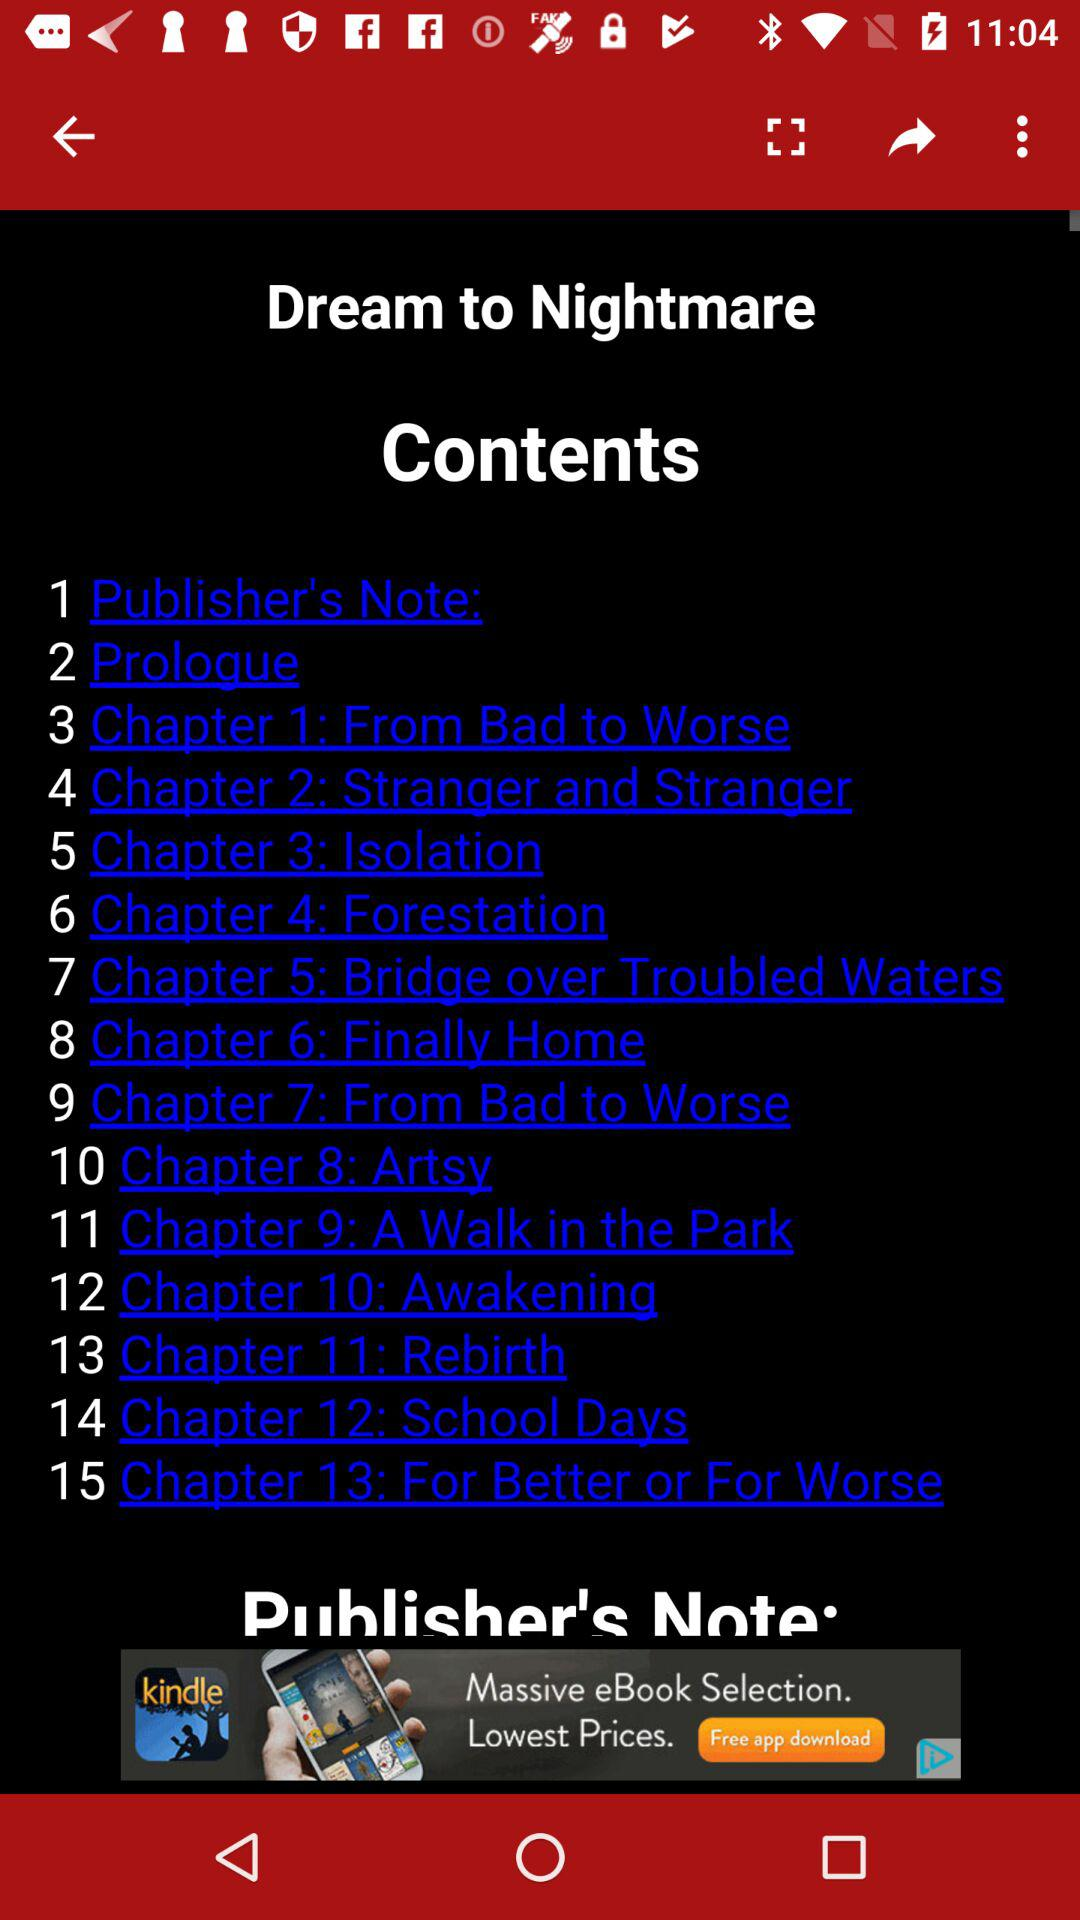What is the title shown on the screen? The title shown on the screen is "Dream to Nightmare". 